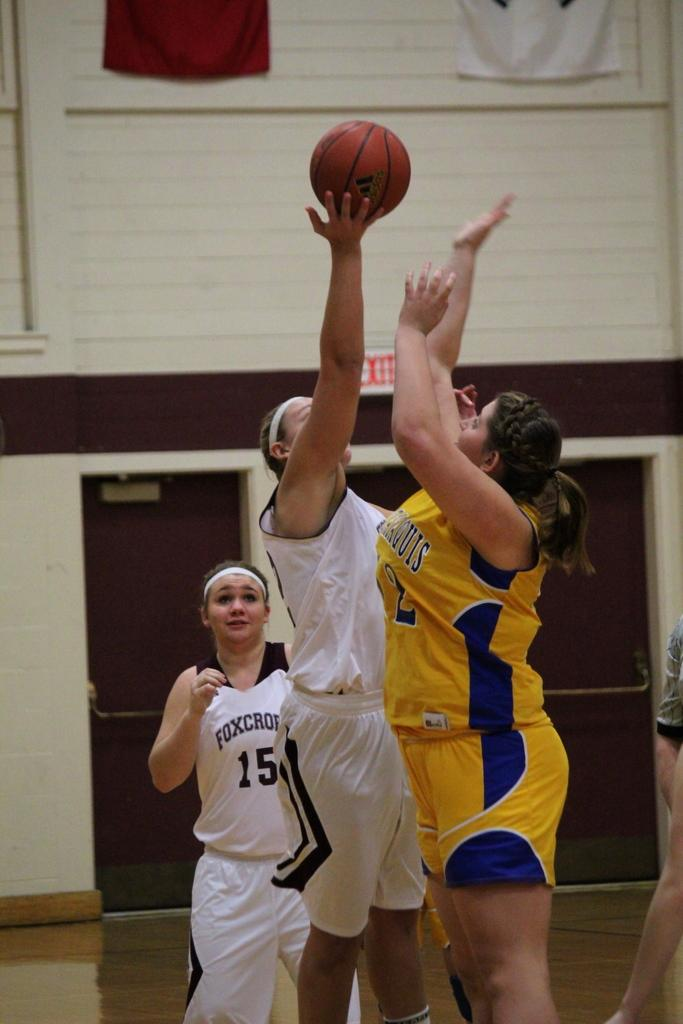<image>
Share a concise interpretation of the image provided. A woman in a Foxcrop basketball jersey plays basketball. 